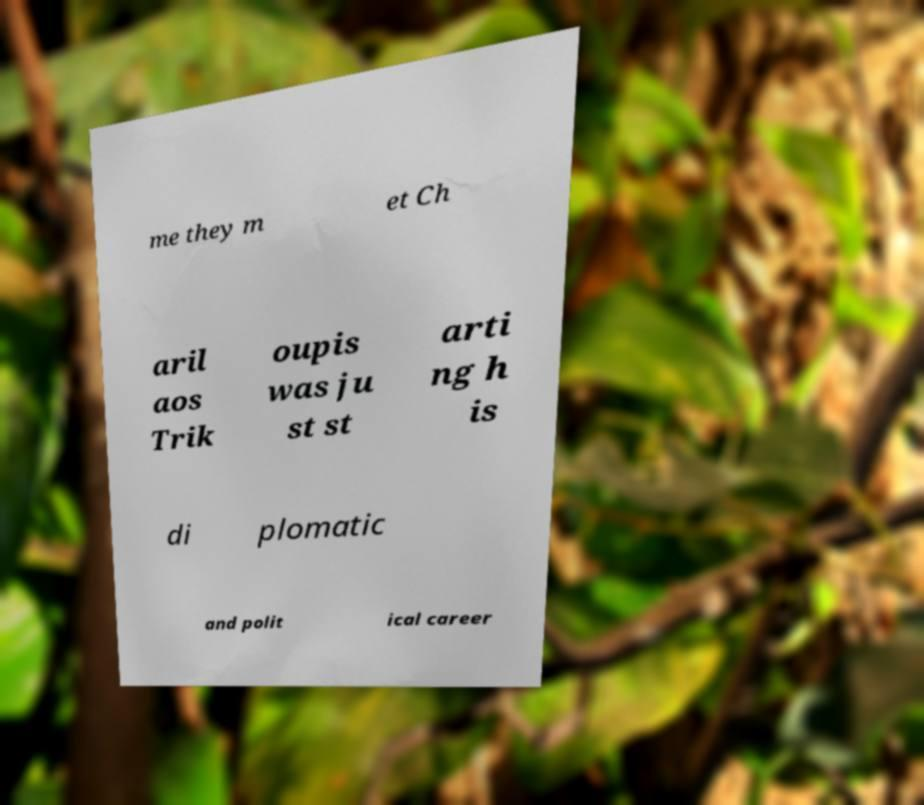What messages or text are displayed in this image? I need them in a readable, typed format. me they m et Ch aril aos Trik oupis was ju st st arti ng h is di plomatic and polit ical career 